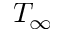<formula> <loc_0><loc_0><loc_500><loc_500>T _ { \infty }</formula> 